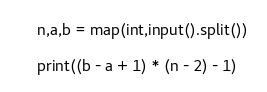<code> <loc_0><loc_0><loc_500><loc_500><_Python_>n,a,b = map(int,input().split())

print((b - a + 1) * (n - 2) - 1)</code> 